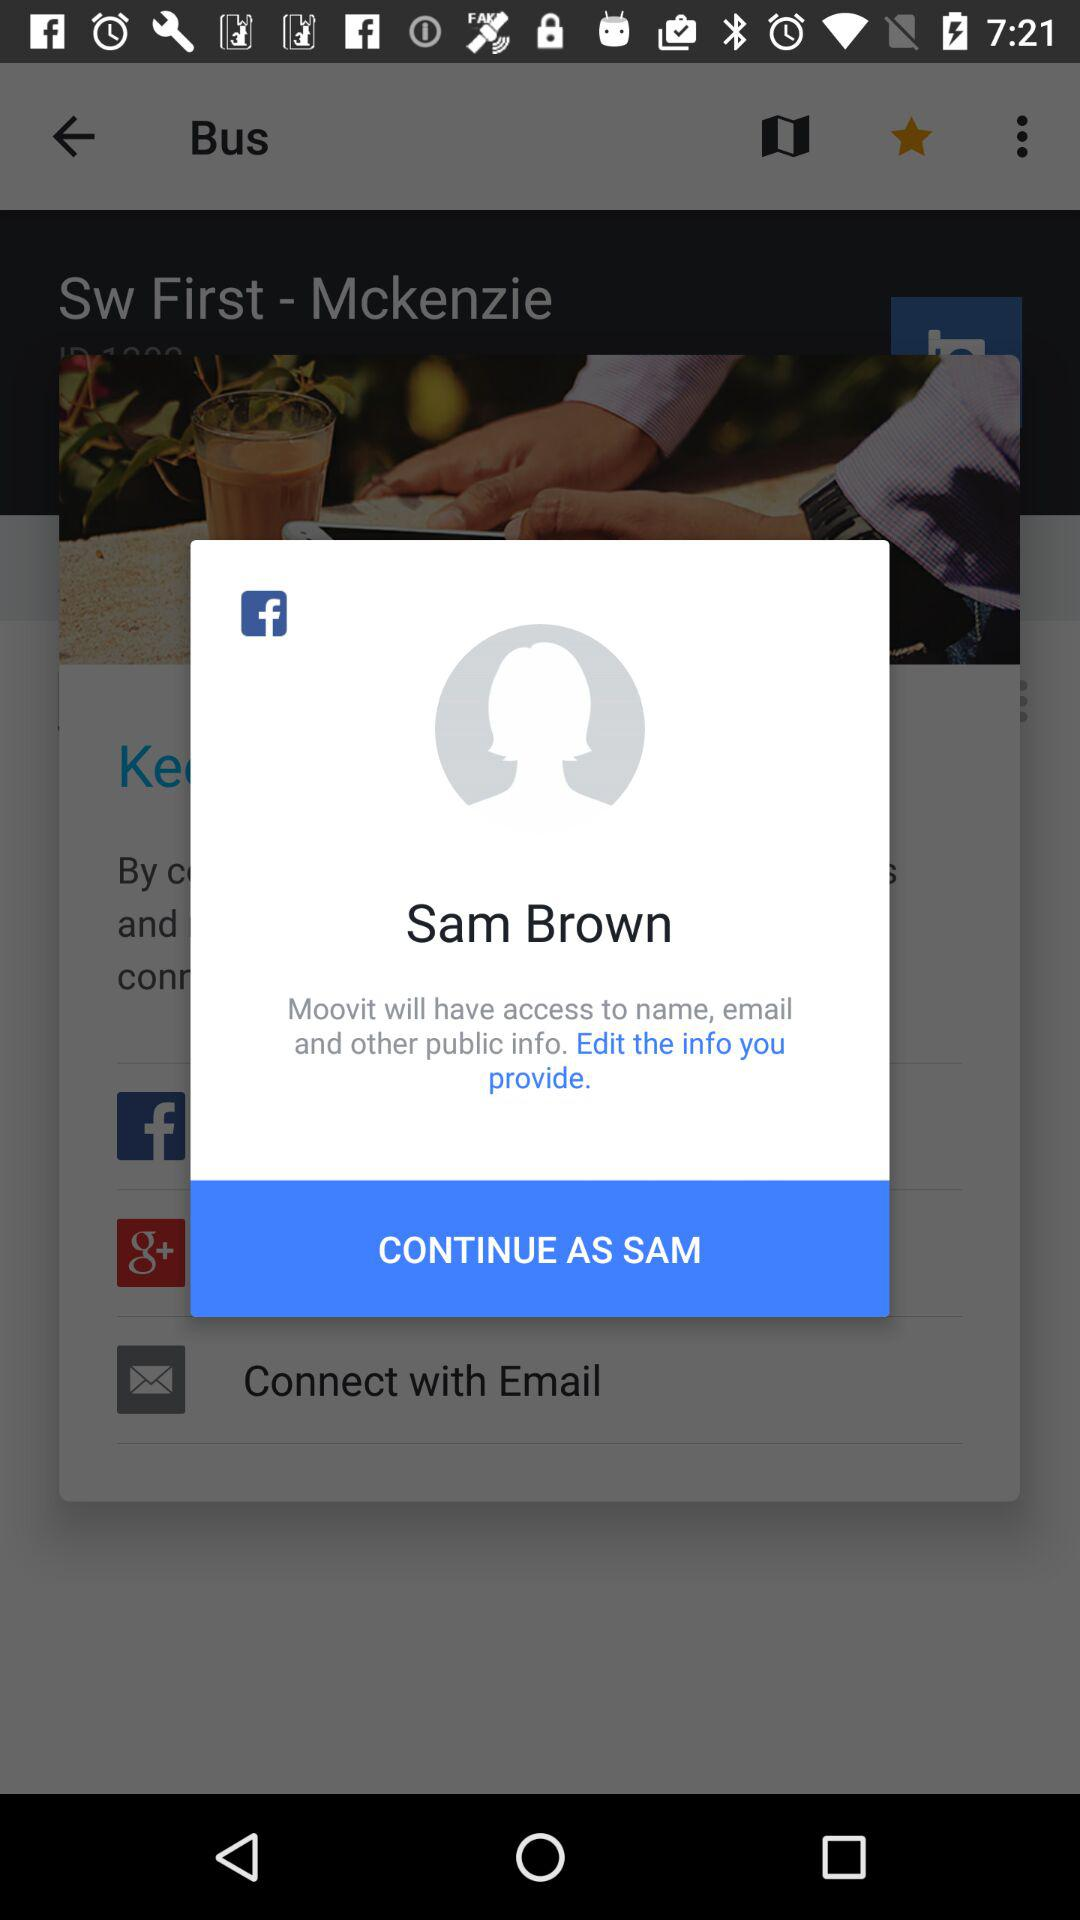What application is asking for permission? The application asking for permission is "Moovit". 